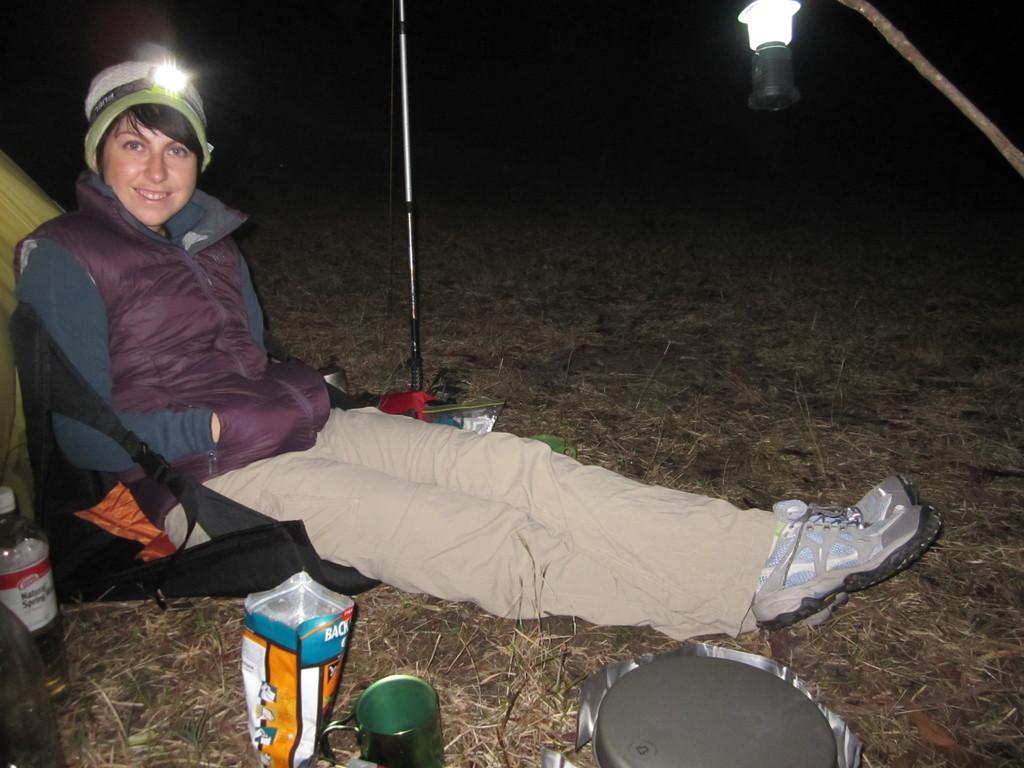Can you describe this image briefly? This is an image clicked in the dark. On the left side there is a person wearing a jacket, sitting, smiling and giving pose for the picture. There is a torch to the person's head. Beside this person bottle, cup, a food packet and some other objects are placed on the ground and also there is a metal stand. At the top there is a light. The background is dark. 